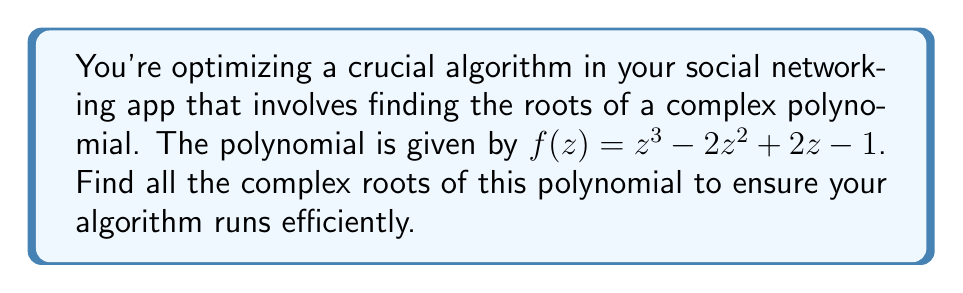Help me with this question. To find the roots of the complex polynomial $f(z) = z^3 - 2z^2 + 2z - 1$, we can use the following steps:

1) First, we can try to factor out any real roots. In this case, we can see that $z = 1$ is a root because $f(1) = 1^3 - 2(1)^2 + 2(1) - 1 = 1 - 2 + 2 - 1 = 0$.

2) Now we can factor out $(z-1)$ from the polynomial:

   $f(z) = (z-1)(z^2 - z + 1)$

3) We now need to solve the quadratic equation $z^2 - z + 1 = 0$.

4) We can use the quadratic formula: $z = \frac{-b \pm \sqrt{b^2 - 4ac}}{2a}$

   Here, $a = 1$, $b = -1$, and $c = 1$

5) Substituting into the formula:

   $z = \frac{1 \pm \sqrt{1^2 - 4(1)(1)}}{2(1)} = \frac{1 \pm \sqrt{-3}}{2}$

6) Simplify:

   $z = \frac{1 \pm i\sqrt{3}}{2}$

7) Therefore, the two complex roots are:

   $z_1 = \frac{1 + i\sqrt{3}}{2}$ and $z_2 = \frac{1 - i\sqrt{3}}{2}$

These are the complex cube roots of unity, often denoted as $\omega$ and $\omega^2$.
Answer: $1, \frac{1 + i\sqrt{3}}{2}, \frac{1 - i\sqrt{3}}{2}$ 